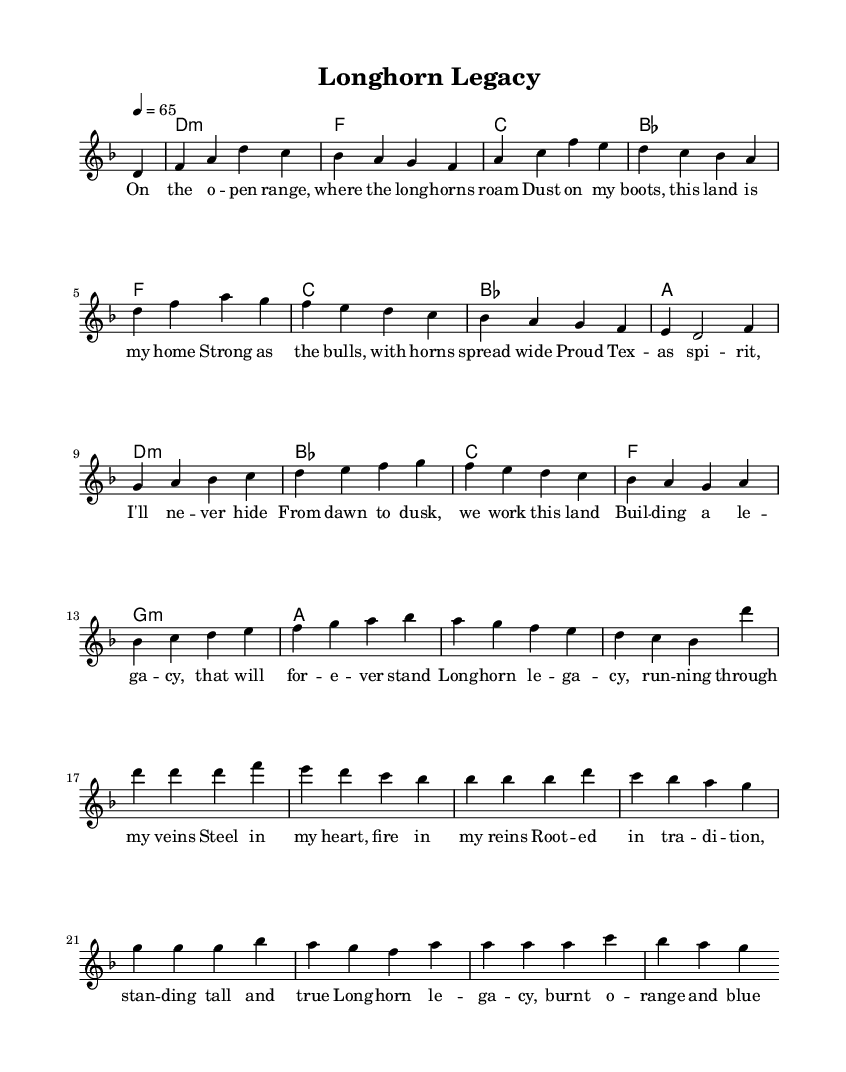What is the key signature of this music? The key signature is indicated at the beginning of the score. Here, it shows a single flat, which corresponds to the key of D minor.
Answer: D minor What is the time signature of the piece? The time signature is found at the beginning of the score after the key signature. It indicates that there are four beats per measure, which is specified as 4/4.
Answer: 4/4 What is the tempo marking? The tempo is specified above the staff, indicating that the piece should be played at a speed of 65 beats per minute (BPM) using quarter notes.
Answer: 65 How many verses are present in the lyrics? The lyrics are structured into three distinct sections: verse, prechorus, and chorus. The presence of only one section labeled as 'verse' indicates that there is one verse in the lyrics.
Answer: 1 What thematic element does the chorus emphasize? By analyzing the lyrics in the chorus, the dominant theme can be identified. The repeated phrases highlight a strong connection to the longhorn legacy, emphasizing pride and tradition, which is the main thematic element.
Answer: Longhorn legacy What is the last note of the melody in the chorus? By examining the melody line in the score towards the end of the chorus, we can see that the last note is a G note, providing the final resolution of the musical phrase.
Answer: G 